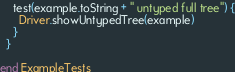Convert code to text. <code><loc_0><loc_0><loc_500><loc_500><_Scala_>    test(example.toString + " untyped full tree") {
      Driver.showUntypedTree(example)
    }
  }

end ExampleTests
</code> 